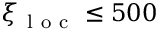<formula> <loc_0><loc_0><loc_500><loc_500>\xi _ { l o c } \leq 5 0 0</formula> 